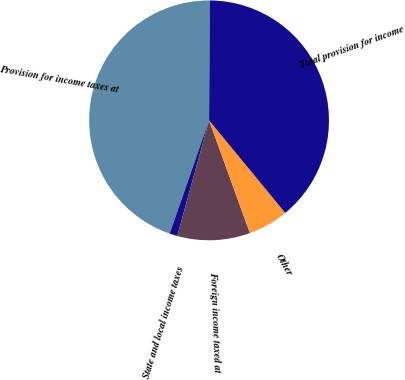Convert chart. <chart><loc_0><loc_0><loc_500><loc_500><pie_chart><fcel>Provision for income taxes at<fcel>State and local income taxes<fcel>Foreign income taxed at<fcel>Other<fcel>Total provision for income<nl><fcel>44.78%<fcel>1.06%<fcel>9.8%<fcel>5.43%<fcel>38.93%<nl></chart> 